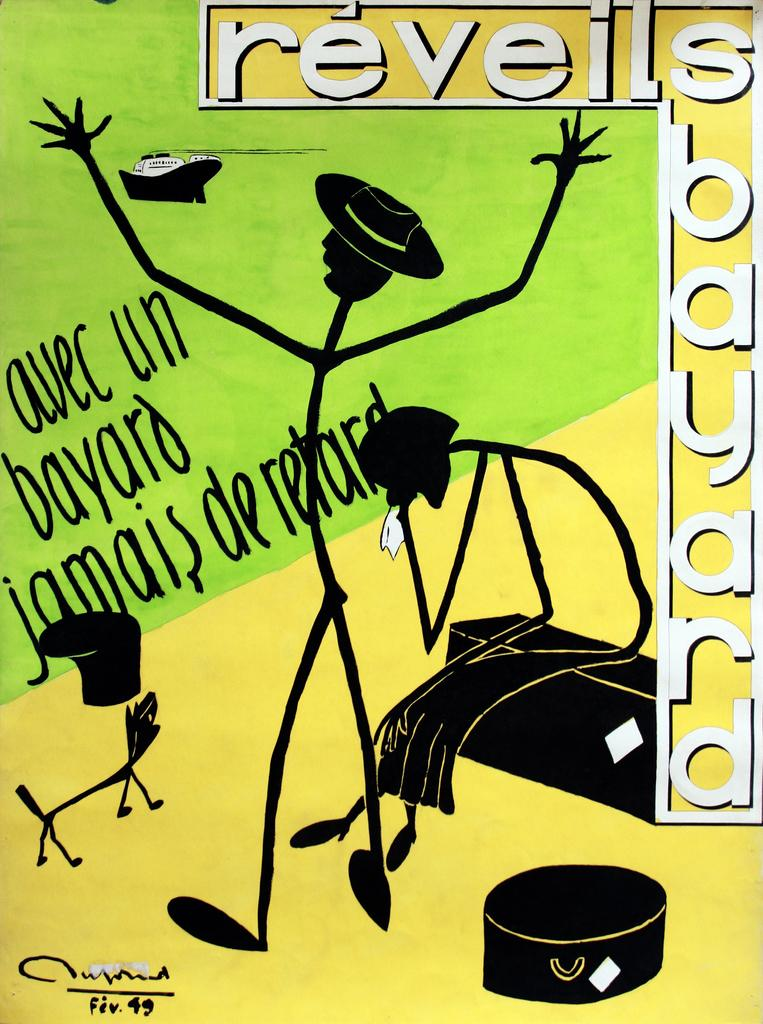What is present on the poster in the image? There is a poster in the image. What can be found on the poster besides the cartoon images? The poster contains text. What type of pie is being served on the poster? There is no pie present on the poster; it contains text and cartoon images. 